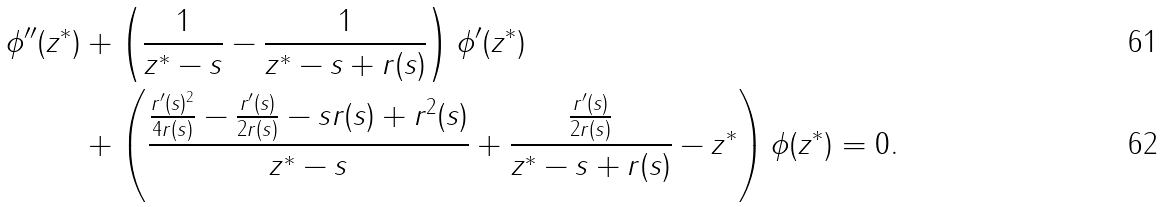Convert formula to latex. <formula><loc_0><loc_0><loc_500><loc_500>\phi ^ { \prime \prime } ( z ^ { * } ) & + \left ( \frac { 1 } { z ^ { * } - s } - \frac { 1 } { z ^ { * } - s + r ( s ) } \right ) \phi ^ { \prime } ( z ^ { * } ) \\ & + \left ( \frac { \frac { r ^ { \prime } ( s ) ^ { 2 } } { 4 r ( s ) } - \frac { r ^ { \prime } ( s ) } { 2 r ( s ) } - s r ( s ) + r ^ { 2 } ( s ) } { z ^ { * } - s } + \frac { \frac { r ^ { \prime } ( s ) } { 2 r ( s ) } } { z ^ { * } - s + r ( s ) } - z ^ { * } \right ) \phi ( z ^ { * } ) = 0 .</formula> 